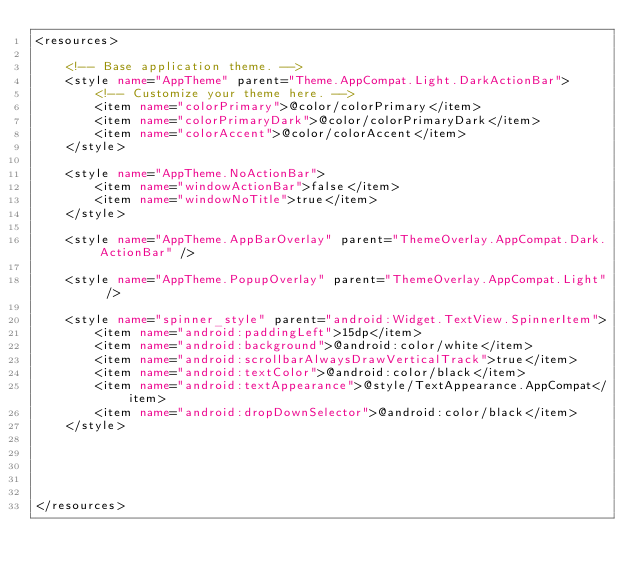<code> <loc_0><loc_0><loc_500><loc_500><_XML_><resources>

    <!-- Base application theme. -->
    <style name="AppTheme" parent="Theme.AppCompat.Light.DarkActionBar">
        <!-- Customize your theme here. -->
        <item name="colorPrimary">@color/colorPrimary</item>
        <item name="colorPrimaryDark">@color/colorPrimaryDark</item>
        <item name="colorAccent">@color/colorAccent</item>
    </style>

    <style name="AppTheme.NoActionBar">
        <item name="windowActionBar">false</item>
        <item name="windowNoTitle">true</item>
    </style>

    <style name="AppTheme.AppBarOverlay" parent="ThemeOverlay.AppCompat.Dark.ActionBar" />

    <style name="AppTheme.PopupOverlay" parent="ThemeOverlay.AppCompat.Light" />

    <style name="spinner_style" parent="android:Widget.TextView.SpinnerItem">
        <item name="android:paddingLeft">15dp</item>
        <item name="android:background">@android:color/white</item>
        <item name="android:scrollbarAlwaysDrawVerticalTrack">true</item>
        <item name="android:textColor">@android:color/black</item>
        <item name="android:textAppearance">@style/TextAppearance.AppCompat</item>
        <item name="android:dropDownSelector">@android:color/black</item>
    </style>





</resources>
</code> 